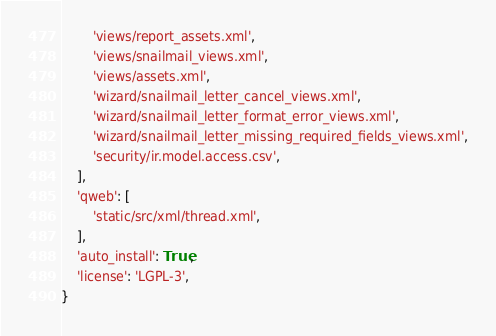<code> <loc_0><loc_0><loc_500><loc_500><_Python_>        'views/report_assets.xml',
        'views/snailmail_views.xml',
        'views/assets.xml',
        'wizard/snailmail_letter_cancel_views.xml',
        'wizard/snailmail_letter_format_error_views.xml',
        'wizard/snailmail_letter_missing_required_fields_views.xml',
        'security/ir.model.access.csv',
    ],
    'qweb': [
        'static/src/xml/thread.xml',
    ],
    'auto_install': True,
    'license': 'LGPL-3',
}
</code> 